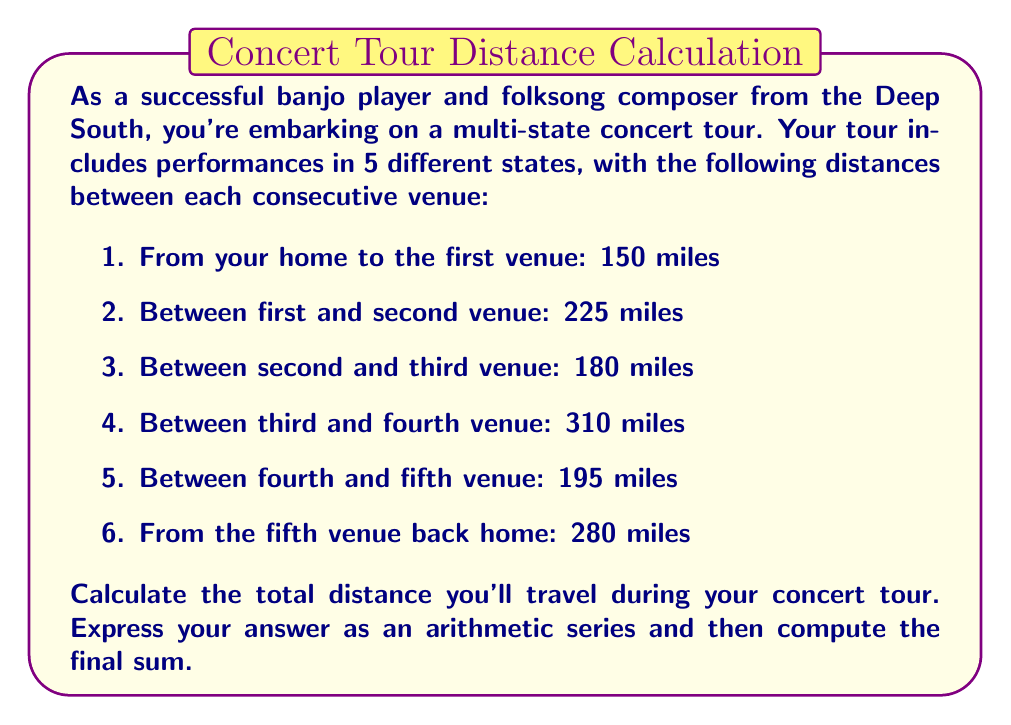Show me your answer to this math problem. Let's approach this step-by-step:

1) First, we need to identify the terms of our arithmetic series. In this case, each term represents a distance traveled:

   $a_1 = 150, a_2 = 225, a_3 = 180, a_4 = 310, a_5 = 195, a_6 = 280$

2) We can write this as an arithmetic series:

   $S = 150 + 225 + 180 + 310 + 195 + 280$

3) To compute the sum, we can use the formula for the sum of an arithmetic series:

   $S_n = \frac{n}{2}(a_1 + a_n)$

   Where $n$ is the number of terms, $a_1$ is the first term, and $a_n$ is the last term.

4) In our case:
   $n = 6$
   $a_1 = 150$
   $a_6 = 280$

5) Plugging these into our formula:

   $S_6 = \frac{6}{2}(150 + 280)$

6) Simplifying:

   $S_6 = 3(430) = 1290$

Therefore, the total distance traveled during your concert tour is 1290 miles.
Answer: The total distance traveled is 1290 miles. 